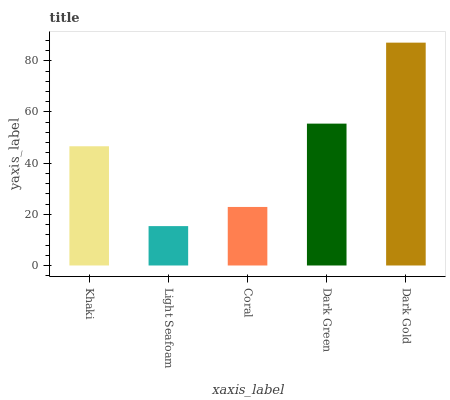Is Light Seafoam the minimum?
Answer yes or no. Yes. Is Dark Gold the maximum?
Answer yes or no. Yes. Is Coral the minimum?
Answer yes or no. No. Is Coral the maximum?
Answer yes or no. No. Is Coral greater than Light Seafoam?
Answer yes or no. Yes. Is Light Seafoam less than Coral?
Answer yes or no. Yes. Is Light Seafoam greater than Coral?
Answer yes or no. No. Is Coral less than Light Seafoam?
Answer yes or no. No. Is Khaki the high median?
Answer yes or no. Yes. Is Khaki the low median?
Answer yes or no. Yes. Is Dark Green the high median?
Answer yes or no. No. Is Coral the low median?
Answer yes or no. No. 